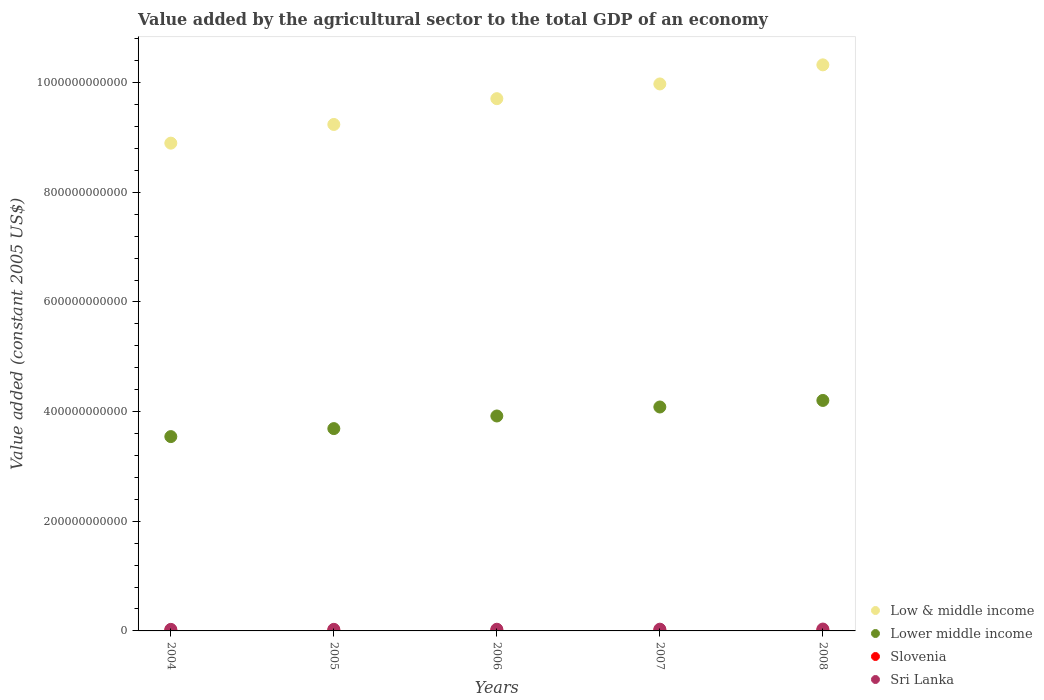How many different coloured dotlines are there?
Offer a terse response. 4. Is the number of dotlines equal to the number of legend labels?
Your answer should be very brief. Yes. What is the value added by the agricultural sector in Low & middle income in 2008?
Your answer should be very brief. 1.03e+12. Across all years, what is the maximum value added by the agricultural sector in Lower middle income?
Ensure brevity in your answer.  4.20e+11. Across all years, what is the minimum value added by the agricultural sector in Low & middle income?
Offer a terse response. 8.90e+11. In which year was the value added by the agricultural sector in Slovenia maximum?
Keep it short and to the point. 2004. What is the total value added by the agricultural sector in Slovenia in the graph?
Provide a succinct answer. 4.28e+09. What is the difference between the value added by the agricultural sector in Low & middle income in 2006 and that in 2008?
Offer a terse response. -6.17e+1. What is the difference between the value added by the agricultural sector in Low & middle income in 2004 and the value added by the agricultural sector in Slovenia in 2005?
Your answer should be very brief. 8.89e+11. What is the average value added by the agricultural sector in Lower middle income per year?
Provide a short and direct response. 3.89e+11. In the year 2004, what is the difference between the value added by the agricultural sector in Slovenia and value added by the agricultural sector in Lower middle income?
Provide a short and direct response. -3.54e+11. What is the ratio of the value added by the agricultural sector in Slovenia in 2005 to that in 2007?
Keep it short and to the point. 0.96. Is the value added by the agricultural sector in Sri Lanka in 2004 less than that in 2008?
Your response must be concise. Yes. What is the difference between the highest and the second highest value added by the agricultural sector in Sri Lanka?
Give a very brief answer. 2.39e+08. What is the difference between the highest and the lowest value added by the agricultural sector in Slovenia?
Offer a very short reply. 5.58e+07. In how many years, is the value added by the agricultural sector in Sri Lanka greater than the average value added by the agricultural sector in Sri Lanka taken over all years?
Ensure brevity in your answer.  2. Is the sum of the value added by the agricultural sector in Low & middle income in 2005 and 2008 greater than the maximum value added by the agricultural sector in Slovenia across all years?
Provide a short and direct response. Yes. Is it the case that in every year, the sum of the value added by the agricultural sector in Low & middle income and value added by the agricultural sector in Slovenia  is greater than the sum of value added by the agricultural sector in Sri Lanka and value added by the agricultural sector in Lower middle income?
Your response must be concise. Yes. Is it the case that in every year, the sum of the value added by the agricultural sector in Slovenia and value added by the agricultural sector in Sri Lanka  is greater than the value added by the agricultural sector in Low & middle income?
Your answer should be compact. No. Does the value added by the agricultural sector in Sri Lanka monotonically increase over the years?
Provide a succinct answer. Yes. Is the value added by the agricultural sector in Low & middle income strictly greater than the value added by the agricultural sector in Lower middle income over the years?
Your answer should be compact. Yes. How many years are there in the graph?
Your answer should be compact. 5. What is the difference between two consecutive major ticks on the Y-axis?
Provide a succinct answer. 2.00e+11. Are the values on the major ticks of Y-axis written in scientific E-notation?
Ensure brevity in your answer.  No. Does the graph contain any zero values?
Your response must be concise. No. Does the graph contain grids?
Provide a succinct answer. No. Where does the legend appear in the graph?
Your answer should be very brief. Bottom right. What is the title of the graph?
Your answer should be very brief. Value added by the agricultural sector to the total GDP of an economy. Does "Bahrain" appear as one of the legend labels in the graph?
Your answer should be compact. No. What is the label or title of the X-axis?
Provide a succinct answer. Years. What is the label or title of the Y-axis?
Provide a short and direct response. Value added (constant 2005 US$). What is the Value added (constant 2005 US$) of Low & middle income in 2004?
Offer a terse response. 8.90e+11. What is the Value added (constant 2005 US$) in Lower middle income in 2004?
Provide a short and direct response. 3.54e+11. What is the Value added (constant 2005 US$) of Slovenia in 2004?
Your response must be concise. 8.80e+08. What is the Value added (constant 2005 US$) of Sri Lanka in 2004?
Make the answer very short. 2.83e+09. What is the Value added (constant 2005 US$) of Low & middle income in 2005?
Your response must be concise. 9.24e+11. What is the Value added (constant 2005 US$) of Lower middle income in 2005?
Offer a terse response. 3.69e+11. What is the Value added (constant 2005 US$) of Slovenia in 2005?
Your answer should be very brief. 8.31e+08. What is the Value added (constant 2005 US$) of Sri Lanka in 2005?
Provide a short and direct response. 2.88e+09. What is the Value added (constant 2005 US$) in Low & middle income in 2006?
Make the answer very short. 9.71e+11. What is the Value added (constant 2005 US$) of Lower middle income in 2006?
Keep it short and to the point. 3.92e+11. What is the Value added (constant 2005 US$) of Slovenia in 2006?
Provide a succinct answer. 8.24e+08. What is the Value added (constant 2005 US$) in Sri Lanka in 2006?
Make the answer very short. 3.07e+09. What is the Value added (constant 2005 US$) of Low & middle income in 2007?
Ensure brevity in your answer.  9.98e+11. What is the Value added (constant 2005 US$) in Lower middle income in 2007?
Your answer should be compact. 4.08e+11. What is the Value added (constant 2005 US$) of Slovenia in 2007?
Your answer should be very brief. 8.68e+08. What is the Value added (constant 2005 US$) in Sri Lanka in 2007?
Keep it short and to the point. 3.17e+09. What is the Value added (constant 2005 US$) of Low & middle income in 2008?
Your answer should be compact. 1.03e+12. What is the Value added (constant 2005 US$) of Lower middle income in 2008?
Your answer should be very brief. 4.20e+11. What is the Value added (constant 2005 US$) in Slovenia in 2008?
Ensure brevity in your answer.  8.73e+08. What is the Value added (constant 2005 US$) in Sri Lanka in 2008?
Keep it short and to the point. 3.41e+09. Across all years, what is the maximum Value added (constant 2005 US$) in Low & middle income?
Provide a short and direct response. 1.03e+12. Across all years, what is the maximum Value added (constant 2005 US$) in Lower middle income?
Offer a very short reply. 4.20e+11. Across all years, what is the maximum Value added (constant 2005 US$) of Slovenia?
Keep it short and to the point. 8.80e+08. Across all years, what is the maximum Value added (constant 2005 US$) in Sri Lanka?
Your answer should be compact. 3.41e+09. Across all years, what is the minimum Value added (constant 2005 US$) in Low & middle income?
Keep it short and to the point. 8.90e+11. Across all years, what is the minimum Value added (constant 2005 US$) in Lower middle income?
Your answer should be very brief. 3.54e+11. Across all years, what is the minimum Value added (constant 2005 US$) in Slovenia?
Ensure brevity in your answer.  8.24e+08. Across all years, what is the minimum Value added (constant 2005 US$) in Sri Lanka?
Provide a short and direct response. 2.83e+09. What is the total Value added (constant 2005 US$) of Low & middle income in the graph?
Your response must be concise. 4.81e+12. What is the total Value added (constant 2005 US$) of Lower middle income in the graph?
Give a very brief answer. 1.94e+12. What is the total Value added (constant 2005 US$) of Slovenia in the graph?
Make the answer very short. 4.28e+09. What is the total Value added (constant 2005 US$) of Sri Lanka in the graph?
Give a very brief answer. 1.54e+1. What is the difference between the Value added (constant 2005 US$) of Low & middle income in 2004 and that in 2005?
Give a very brief answer. -3.41e+1. What is the difference between the Value added (constant 2005 US$) of Lower middle income in 2004 and that in 2005?
Provide a succinct answer. -1.46e+1. What is the difference between the Value added (constant 2005 US$) in Slovenia in 2004 and that in 2005?
Provide a short and direct response. 4.92e+07. What is the difference between the Value added (constant 2005 US$) of Sri Lanka in 2004 and that in 2005?
Keep it short and to the point. -5.15e+07. What is the difference between the Value added (constant 2005 US$) in Low & middle income in 2004 and that in 2006?
Offer a terse response. -8.11e+1. What is the difference between the Value added (constant 2005 US$) of Lower middle income in 2004 and that in 2006?
Your answer should be compact. -3.76e+1. What is the difference between the Value added (constant 2005 US$) of Slovenia in 2004 and that in 2006?
Provide a short and direct response. 5.58e+07. What is the difference between the Value added (constant 2005 US$) in Sri Lanka in 2004 and that in 2006?
Give a very brief answer. -2.34e+08. What is the difference between the Value added (constant 2005 US$) of Low & middle income in 2004 and that in 2007?
Give a very brief answer. -1.08e+11. What is the difference between the Value added (constant 2005 US$) of Lower middle income in 2004 and that in 2007?
Provide a succinct answer. -5.40e+1. What is the difference between the Value added (constant 2005 US$) in Slovenia in 2004 and that in 2007?
Offer a terse response. 1.13e+07. What is the difference between the Value added (constant 2005 US$) in Sri Lanka in 2004 and that in 2007?
Ensure brevity in your answer.  -3.38e+08. What is the difference between the Value added (constant 2005 US$) in Low & middle income in 2004 and that in 2008?
Ensure brevity in your answer.  -1.43e+11. What is the difference between the Value added (constant 2005 US$) in Lower middle income in 2004 and that in 2008?
Offer a very short reply. -6.59e+1. What is the difference between the Value added (constant 2005 US$) in Slovenia in 2004 and that in 2008?
Your answer should be very brief. 6.95e+06. What is the difference between the Value added (constant 2005 US$) of Sri Lanka in 2004 and that in 2008?
Ensure brevity in your answer.  -5.77e+08. What is the difference between the Value added (constant 2005 US$) in Low & middle income in 2005 and that in 2006?
Offer a very short reply. -4.70e+1. What is the difference between the Value added (constant 2005 US$) in Lower middle income in 2005 and that in 2006?
Provide a succinct answer. -2.30e+1. What is the difference between the Value added (constant 2005 US$) in Slovenia in 2005 and that in 2006?
Provide a short and direct response. 6.61e+06. What is the difference between the Value added (constant 2005 US$) of Sri Lanka in 2005 and that in 2006?
Give a very brief answer. -1.82e+08. What is the difference between the Value added (constant 2005 US$) of Low & middle income in 2005 and that in 2007?
Keep it short and to the point. -7.39e+1. What is the difference between the Value added (constant 2005 US$) in Lower middle income in 2005 and that in 2007?
Provide a succinct answer. -3.94e+1. What is the difference between the Value added (constant 2005 US$) of Slovenia in 2005 and that in 2007?
Keep it short and to the point. -3.79e+07. What is the difference between the Value added (constant 2005 US$) of Sri Lanka in 2005 and that in 2007?
Your answer should be compact. -2.86e+08. What is the difference between the Value added (constant 2005 US$) of Low & middle income in 2005 and that in 2008?
Offer a terse response. -1.09e+11. What is the difference between the Value added (constant 2005 US$) in Lower middle income in 2005 and that in 2008?
Your answer should be compact. -5.14e+1. What is the difference between the Value added (constant 2005 US$) in Slovenia in 2005 and that in 2008?
Offer a terse response. -4.22e+07. What is the difference between the Value added (constant 2005 US$) of Sri Lanka in 2005 and that in 2008?
Offer a terse response. -5.25e+08. What is the difference between the Value added (constant 2005 US$) in Low & middle income in 2006 and that in 2007?
Your answer should be very brief. -2.69e+1. What is the difference between the Value added (constant 2005 US$) of Lower middle income in 2006 and that in 2007?
Give a very brief answer. -1.64e+1. What is the difference between the Value added (constant 2005 US$) of Slovenia in 2006 and that in 2007?
Your response must be concise. -4.45e+07. What is the difference between the Value added (constant 2005 US$) of Sri Lanka in 2006 and that in 2007?
Offer a very short reply. -1.04e+08. What is the difference between the Value added (constant 2005 US$) in Low & middle income in 2006 and that in 2008?
Your answer should be very brief. -6.17e+1. What is the difference between the Value added (constant 2005 US$) in Lower middle income in 2006 and that in 2008?
Your response must be concise. -2.84e+1. What is the difference between the Value added (constant 2005 US$) of Slovenia in 2006 and that in 2008?
Offer a terse response. -4.88e+07. What is the difference between the Value added (constant 2005 US$) of Sri Lanka in 2006 and that in 2008?
Your answer should be compact. -3.43e+08. What is the difference between the Value added (constant 2005 US$) in Low & middle income in 2007 and that in 2008?
Ensure brevity in your answer.  -3.48e+1. What is the difference between the Value added (constant 2005 US$) in Lower middle income in 2007 and that in 2008?
Your answer should be compact. -1.20e+1. What is the difference between the Value added (constant 2005 US$) in Slovenia in 2007 and that in 2008?
Offer a very short reply. -4.32e+06. What is the difference between the Value added (constant 2005 US$) of Sri Lanka in 2007 and that in 2008?
Your answer should be compact. -2.39e+08. What is the difference between the Value added (constant 2005 US$) of Low & middle income in 2004 and the Value added (constant 2005 US$) of Lower middle income in 2005?
Your answer should be compact. 5.21e+11. What is the difference between the Value added (constant 2005 US$) of Low & middle income in 2004 and the Value added (constant 2005 US$) of Slovenia in 2005?
Offer a terse response. 8.89e+11. What is the difference between the Value added (constant 2005 US$) of Low & middle income in 2004 and the Value added (constant 2005 US$) of Sri Lanka in 2005?
Your answer should be compact. 8.87e+11. What is the difference between the Value added (constant 2005 US$) in Lower middle income in 2004 and the Value added (constant 2005 US$) in Slovenia in 2005?
Ensure brevity in your answer.  3.54e+11. What is the difference between the Value added (constant 2005 US$) of Lower middle income in 2004 and the Value added (constant 2005 US$) of Sri Lanka in 2005?
Ensure brevity in your answer.  3.52e+11. What is the difference between the Value added (constant 2005 US$) in Slovenia in 2004 and the Value added (constant 2005 US$) in Sri Lanka in 2005?
Your answer should be very brief. -2.00e+09. What is the difference between the Value added (constant 2005 US$) of Low & middle income in 2004 and the Value added (constant 2005 US$) of Lower middle income in 2006?
Your answer should be compact. 4.98e+11. What is the difference between the Value added (constant 2005 US$) in Low & middle income in 2004 and the Value added (constant 2005 US$) in Slovenia in 2006?
Provide a short and direct response. 8.89e+11. What is the difference between the Value added (constant 2005 US$) in Low & middle income in 2004 and the Value added (constant 2005 US$) in Sri Lanka in 2006?
Your answer should be very brief. 8.87e+11. What is the difference between the Value added (constant 2005 US$) of Lower middle income in 2004 and the Value added (constant 2005 US$) of Slovenia in 2006?
Offer a very short reply. 3.54e+11. What is the difference between the Value added (constant 2005 US$) in Lower middle income in 2004 and the Value added (constant 2005 US$) in Sri Lanka in 2006?
Your response must be concise. 3.51e+11. What is the difference between the Value added (constant 2005 US$) of Slovenia in 2004 and the Value added (constant 2005 US$) of Sri Lanka in 2006?
Your answer should be compact. -2.19e+09. What is the difference between the Value added (constant 2005 US$) of Low & middle income in 2004 and the Value added (constant 2005 US$) of Lower middle income in 2007?
Offer a terse response. 4.81e+11. What is the difference between the Value added (constant 2005 US$) in Low & middle income in 2004 and the Value added (constant 2005 US$) in Slovenia in 2007?
Offer a terse response. 8.89e+11. What is the difference between the Value added (constant 2005 US$) in Low & middle income in 2004 and the Value added (constant 2005 US$) in Sri Lanka in 2007?
Provide a succinct answer. 8.87e+11. What is the difference between the Value added (constant 2005 US$) of Lower middle income in 2004 and the Value added (constant 2005 US$) of Slovenia in 2007?
Ensure brevity in your answer.  3.54e+11. What is the difference between the Value added (constant 2005 US$) in Lower middle income in 2004 and the Value added (constant 2005 US$) in Sri Lanka in 2007?
Keep it short and to the point. 3.51e+11. What is the difference between the Value added (constant 2005 US$) in Slovenia in 2004 and the Value added (constant 2005 US$) in Sri Lanka in 2007?
Your answer should be very brief. -2.29e+09. What is the difference between the Value added (constant 2005 US$) in Low & middle income in 2004 and the Value added (constant 2005 US$) in Lower middle income in 2008?
Offer a very short reply. 4.69e+11. What is the difference between the Value added (constant 2005 US$) in Low & middle income in 2004 and the Value added (constant 2005 US$) in Slovenia in 2008?
Provide a short and direct response. 8.89e+11. What is the difference between the Value added (constant 2005 US$) in Low & middle income in 2004 and the Value added (constant 2005 US$) in Sri Lanka in 2008?
Provide a short and direct response. 8.86e+11. What is the difference between the Value added (constant 2005 US$) in Lower middle income in 2004 and the Value added (constant 2005 US$) in Slovenia in 2008?
Your response must be concise. 3.54e+11. What is the difference between the Value added (constant 2005 US$) of Lower middle income in 2004 and the Value added (constant 2005 US$) of Sri Lanka in 2008?
Give a very brief answer. 3.51e+11. What is the difference between the Value added (constant 2005 US$) of Slovenia in 2004 and the Value added (constant 2005 US$) of Sri Lanka in 2008?
Provide a short and direct response. -2.53e+09. What is the difference between the Value added (constant 2005 US$) of Low & middle income in 2005 and the Value added (constant 2005 US$) of Lower middle income in 2006?
Your answer should be very brief. 5.32e+11. What is the difference between the Value added (constant 2005 US$) of Low & middle income in 2005 and the Value added (constant 2005 US$) of Slovenia in 2006?
Provide a short and direct response. 9.23e+11. What is the difference between the Value added (constant 2005 US$) of Low & middle income in 2005 and the Value added (constant 2005 US$) of Sri Lanka in 2006?
Keep it short and to the point. 9.21e+11. What is the difference between the Value added (constant 2005 US$) of Lower middle income in 2005 and the Value added (constant 2005 US$) of Slovenia in 2006?
Ensure brevity in your answer.  3.68e+11. What is the difference between the Value added (constant 2005 US$) in Lower middle income in 2005 and the Value added (constant 2005 US$) in Sri Lanka in 2006?
Provide a short and direct response. 3.66e+11. What is the difference between the Value added (constant 2005 US$) of Slovenia in 2005 and the Value added (constant 2005 US$) of Sri Lanka in 2006?
Your answer should be very brief. -2.24e+09. What is the difference between the Value added (constant 2005 US$) in Low & middle income in 2005 and the Value added (constant 2005 US$) in Lower middle income in 2007?
Keep it short and to the point. 5.15e+11. What is the difference between the Value added (constant 2005 US$) of Low & middle income in 2005 and the Value added (constant 2005 US$) of Slovenia in 2007?
Your answer should be very brief. 9.23e+11. What is the difference between the Value added (constant 2005 US$) in Low & middle income in 2005 and the Value added (constant 2005 US$) in Sri Lanka in 2007?
Offer a terse response. 9.21e+11. What is the difference between the Value added (constant 2005 US$) of Lower middle income in 2005 and the Value added (constant 2005 US$) of Slovenia in 2007?
Provide a short and direct response. 3.68e+11. What is the difference between the Value added (constant 2005 US$) of Lower middle income in 2005 and the Value added (constant 2005 US$) of Sri Lanka in 2007?
Provide a succinct answer. 3.66e+11. What is the difference between the Value added (constant 2005 US$) in Slovenia in 2005 and the Value added (constant 2005 US$) in Sri Lanka in 2007?
Offer a terse response. -2.34e+09. What is the difference between the Value added (constant 2005 US$) in Low & middle income in 2005 and the Value added (constant 2005 US$) in Lower middle income in 2008?
Make the answer very short. 5.03e+11. What is the difference between the Value added (constant 2005 US$) of Low & middle income in 2005 and the Value added (constant 2005 US$) of Slovenia in 2008?
Make the answer very short. 9.23e+11. What is the difference between the Value added (constant 2005 US$) of Low & middle income in 2005 and the Value added (constant 2005 US$) of Sri Lanka in 2008?
Provide a succinct answer. 9.20e+11. What is the difference between the Value added (constant 2005 US$) in Lower middle income in 2005 and the Value added (constant 2005 US$) in Slovenia in 2008?
Provide a succinct answer. 3.68e+11. What is the difference between the Value added (constant 2005 US$) in Lower middle income in 2005 and the Value added (constant 2005 US$) in Sri Lanka in 2008?
Provide a succinct answer. 3.66e+11. What is the difference between the Value added (constant 2005 US$) of Slovenia in 2005 and the Value added (constant 2005 US$) of Sri Lanka in 2008?
Offer a terse response. -2.58e+09. What is the difference between the Value added (constant 2005 US$) of Low & middle income in 2006 and the Value added (constant 2005 US$) of Lower middle income in 2007?
Offer a terse response. 5.62e+11. What is the difference between the Value added (constant 2005 US$) of Low & middle income in 2006 and the Value added (constant 2005 US$) of Slovenia in 2007?
Provide a succinct answer. 9.70e+11. What is the difference between the Value added (constant 2005 US$) in Low & middle income in 2006 and the Value added (constant 2005 US$) in Sri Lanka in 2007?
Make the answer very short. 9.68e+11. What is the difference between the Value added (constant 2005 US$) of Lower middle income in 2006 and the Value added (constant 2005 US$) of Slovenia in 2007?
Provide a short and direct response. 3.91e+11. What is the difference between the Value added (constant 2005 US$) in Lower middle income in 2006 and the Value added (constant 2005 US$) in Sri Lanka in 2007?
Your response must be concise. 3.89e+11. What is the difference between the Value added (constant 2005 US$) of Slovenia in 2006 and the Value added (constant 2005 US$) of Sri Lanka in 2007?
Your answer should be compact. -2.35e+09. What is the difference between the Value added (constant 2005 US$) of Low & middle income in 2006 and the Value added (constant 2005 US$) of Lower middle income in 2008?
Offer a terse response. 5.50e+11. What is the difference between the Value added (constant 2005 US$) of Low & middle income in 2006 and the Value added (constant 2005 US$) of Slovenia in 2008?
Provide a short and direct response. 9.70e+11. What is the difference between the Value added (constant 2005 US$) of Low & middle income in 2006 and the Value added (constant 2005 US$) of Sri Lanka in 2008?
Offer a very short reply. 9.67e+11. What is the difference between the Value added (constant 2005 US$) of Lower middle income in 2006 and the Value added (constant 2005 US$) of Slovenia in 2008?
Your answer should be compact. 3.91e+11. What is the difference between the Value added (constant 2005 US$) in Lower middle income in 2006 and the Value added (constant 2005 US$) in Sri Lanka in 2008?
Ensure brevity in your answer.  3.89e+11. What is the difference between the Value added (constant 2005 US$) in Slovenia in 2006 and the Value added (constant 2005 US$) in Sri Lanka in 2008?
Your response must be concise. -2.59e+09. What is the difference between the Value added (constant 2005 US$) in Low & middle income in 2007 and the Value added (constant 2005 US$) in Lower middle income in 2008?
Give a very brief answer. 5.77e+11. What is the difference between the Value added (constant 2005 US$) of Low & middle income in 2007 and the Value added (constant 2005 US$) of Slovenia in 2008?
Your response must be concise. 9.97e+11. What is the difference between the Value added (constant 2005 US$) of Low & middle income in 2007 and the Value added (constant 2005 US$) of Sri Lanka in 2008?
Give a very brief answer. 9.94e+11. What is the difference between the Value added (constant 2005 US$) of Lower middle income in 2007 and the Value added (constant 2005 US$) of Slovenia in 2008?
Your answer should be very brief. 4.08e+11. What is the difference between the Value added (constant 2005 US$) in Lower middle income in 2007 and the Value added (constant 2005 US$) in Sri Lanka in 2008?
Offer a very short reply. 4.05e+11. What is the difference between the Value added (constant 2005 US$) in Slovenia in 2007 and the Value added (constant 2005 US$) in Sri Lanka in 2008?
Ensure brevity in your answer.  -2.54e+09. What is the average Value added (constant 2005 US$) of Low & middle income per year?
Your response must be concise. 9.63e+11. What is the average Value added (constant 2005 US$) of Lower middle income per year?
Keep it short and to the point. 3.89e+11. What is the average Value added (constant 2005 US$) in Slovenia per year?
Your answer should be very brief. 8.55e+08. What is the average Value added (constant 2005 US$) of Sri Lanka per year?
Your answer should be compact. 3.07e+09. In the year 2004, what is the difference between the Value added (constant 2005 US$) in Low & middle income and Value added (constant 2005 US$) in Lower middle income?
Offer a terse response. 5.35e+11. In the year 2004, what is the difference between the Value added (constant 2005 US$) in Low & middle income and Value added (constant 2005 US$) in Slovenia?
Provide a succinct answer. 8.89e+11. In the year 2004, what is the difference between the Value added (constant 2005 US$) in Low & middle income and Value added (constant 2005 US$) in Sri Lanka?
Give a very brief answer. 8.87e+11. In the year 2004, what is the difference between the Value added (constant 2005 US$) in Lower middle income and Value added (constant 2005 US$) in Slovenia?
Ensure brevity in your answer.  3.54e+11. In the year 2004, what is the difference between the Value added (constant 2005 US$) in Lower middle income and Value added (constant 2005 US$) in Sri Lanka?
Ensure brevity in your answer.  3.52e+11. In the year 2004, what is the difference between the Value added (constant 2005 US$) in Slovenia and Value added (constant 2005 US$) in Sri Lanka?
Ensure brevity in your answer.  -1.95e+09. In the year 2005, what is the difference between the Value added (constant 2005 US$) in Low & middle income and Value added (constant 2005 US$) in Lower middle income?
Your response must be concise. 5.55e+11. In the year 2005, what is the difference between the Value added (constant 2005 US$) in Low & middle income and Value added (constant 2005 US$) in Slovenia?
Offer a very short reply. 9.23e+11. In the year 2005, what is the difference between the Value added (constant 2005 US$) of Low & middle income and Value added (constant 2005 US$) of Sri Lanka?
Offer a very short reply. 9.21e+11. In the year 2005, what is the difference between the Value added (constant 2005 US$) of Lower middle income and Value added (constant 2005 US$) of Slovenia?
Your response must be concise. 3.68e+11. In the year 2005, what is the difference between the Value added (constant 2005 US$) in Lower middle income and Value added (constant 2005 US$) in Sri Lanka?
Make the answer very short. 3.66e+11. In the year 2005, what is the difference between the Value added (constant 2005 US$) of Slovenia and Value added (constant 2005 US$) of Sri Lanka?
Give a very brief answer. -2.05e+09. In the year 2006, what is the difference between the Value added (constant 2005 US$) of Low & middle income and Value added (constant 2005 US$) of Lower middle income?
Offer a terse response. 5.79e+11. In the year 2006, what is the difference between the Value added (constant 2005 US$) in Low & middle income and Value added (constant 2005 US$) in Slovenia?
Your answer should be compact. 9.70e+11. In the year 2006, what is the difference between the Value added (constant 2005 US$) of Low & middle income and Value added (constant 2005 US$) of Sri Lanka?
Your answer should be very brief. 9.68e+11. In the year 2006, what is the difference between the Value added (constant 2005 US$) of Lower middle income and Value added (constant 2005 US$) of Slovenia?
Give a very brief answer. 3.91e+11. In the year 2006, what is the difference between the Value added (constant 2005 US$) in Lower middle income and Value added (constant 2005 US$) in Sri Lanka?
Your answer should be compact. 3.89e+11. In the year 2006, what is the difference between the Value added (constant 2005 US$) of Slovenia and Value added (constant 2005 US$) of Sri Lanka?
Provide a short and direct response. -2.24e+09. In the year 2007, what is the difference between the Value added (constant 2005 US$) in Low & middle income and Value added (constant 2005 US$) in Lower middle income?
Offer a terse response. 5.89e+11. In the year 2007, what is the difference between the Value added (constant 2005 US$) of Low & middle income and Value added (constant 2005 US$) of Slovenia?
Your answer should be compact. 9.97e+11. In the year 2007, what is the difference between the Value added (constant 2005 US$) of Low & middle income and Value added (constant 2005 US$) of Sri Lanka?
Offer a very short reply. 9.95e+11. In the year 2007, what is the difference between the Value added (constant 2005 US$) in Lower middle income and Value added (constant 2005 US$) in Slovenia?
Offer a very short reply. 4.08e+11. In the year 2007, what is the difference between the Value added (constant 2005 US$) in Lower middle income and Value added (constant 2005 US$) in Sri Lanka?
Keep it short and to the point. 4.05e+11. In the year 2007, what is the difference between the Value added (constant 2005 US$) of Slovenia and Value added (constant 2005 US$) of Sri Lanka?
Offer a terse response. -2.30e+09. In the year 2008, what is the difference between the Value added (constant 2005 US$) in Low & middle income and Value added (constant 2005 US$) in Lower middle income?
Give a very brief answer. 6.12e+11. In the year 2008, what is the difference between the Value added (constant 2005 US$) in Low & middle income and Value added (constant 2005 US$) in Slovenia?
Keep it short and to the point. 1.03e+12. In the year 2008, what is the difference between the Value added (constant 2005 US$) in Low & middle income and Value added (constant 2005 US$) in Sri Lanka?
Your answer should be compact. 1.03e+12. In the year 2008, what is the difference between the Value added (constant 2005 US$) in Lower middle income and Value added (constant 2005 US$) in Slovenia?
Make the answer very short. 4.20e+11. In the year 2008, what is the difference between the Value added (constant 2005 US$) of Lower middle income and Value added (constant 2005 US$) of Sri Lanka?
Your response must be concise. 4.17e+11. In the year 2008, what is the difference between the Value added (constant 2005 US$) in Slovenia and Value added (constant 2005 US$) in Sri Lanka?
Offer a very short reply. -2.54e+09. What is the ratio of the Value added (constant 2005 US$) of Low & middle income in 2004 to that in 2005?
Give a very brief answer. 0.96. What is the ratio of the Value added (constant 2005 US$) of Lower middle income in 2004 to that in 2005?
Provide a short and direct response. 0.96. What is the ratio of the Value added (constant 2005 US$) of Slovenia in 2004 to that in 2005?
Keep it short and to the point. 1.06. What is the ratio of the Value added (constant 2005 US$) of Sri Lanka in 2004 to that in 2005?
Provide a succinct answer. 0.98. What is the ratio of the Value added (constant 2005 US$) in Low & middle income in 2004 to that in 2006?
Offer a terse response. 0.92. What is the ratio of the Value added (constant 2005 US$) of Lower middle income in 2004 to that in 2006?
Your answer should be very brief. 0.9. What is the ratio of the Value added (constant 2005 US$) of Slovenia in 2004 to that in 2006?
Make the answer very short. 1.07. What is the ratio of the Value added (constant 2005 US$) in Sri Lanka in 2004 to that in 2006?
Keep it short and to the point. 0.92. What is the ratio of the Value added (constant 2005 US$) in Low & middle income in 2004 to that in 2007?
Your response must be concise. 0.89. What is the ratio of the Value added (constant 2005 US$) in Lower middle income in 2004 to that in 2007?
Provide a short and direct response. 0.87. What is the ratio of the Value added (constant 2005 US$) of Slovenia in 2004 to that in 2007?
Your answer should be compact. 1.01. What is the ratio of the Value added (constant 2005 US$) in Sri Lanka in 2004 to that in 2007?
Provide a short and direct response. 0.89. What is the ratio of the Value added (constant 2005 US$) of Low & middle income in 2004 to that in 2008?
Your answer should be very brief. 0.86. What is the ratio of the Value added (constant 2005 US$) of Lower middle income in 2004 to that in 2008?
Provide a succinct answer. 0.84. What is the ratio of the Value added (constant 2005 US$) in Sri Lanka in 2004 to that in 2008?
Make the answer very short. 0.83. What is the ratio of the Value added (constant 2005 US$) of Low & middle income in 2005 to that in 2006?
Your answer should be compact. 0.95. What is the ratio of the Value added (constant 2005 US$) of Lower middle income in 2005 to that in 2006?
Your answer should be compact. 0.94. What is the ratio of the Value added (constant 2005 US$) in Slovenia in 2005 to that in 2006?
Your answer should be compact. 1.01. What is the ratio of the Value added (constant 2005 US$) of Sri Lanka in 2005 to that in 2006?
Give a very brief answer. 0.94. What is the ratio of the Value added (constant 2005 US$) in Low & middle income in 2005 to that in 2007?
Ensure brevity in your answer.  0.93. What is the ratio of the Value added (constant 2005 US$) in Lower middle income in 2005 to that in 2007?
Keep it short and to the point. 0.9. What is the ratio of the Value added (constant 2005 US$) of Slovenia in 2005 to that in 2007?
Ensure brevity in your answer.  0.96. What is the ratio of the Value added (constant 2005 US$) of Sri Lanka in 2005 to that in 2007?
Ensure brevity in your answer.  0.91. What is the ratio of the Value added (constant 2005 US$) in Low & middle income in 2005 to that in 2008?
Give a very brief answer. 0.89. What is the ratio of the Value added (constant 2005 US$) in Lower middle income in 2005 to that in 2008?
Provide a short and direct response. 0.88. What is the ratio of the Value added (constant 2005 US$) in Slovenia in 2005 to that in 2008?
Your response must be concise. 0.95. What is the ratio of the Value added (constant 2005 US$) in Sri Lanka in 2005 to that in 2008?
Offer a very short reply. 0.85. What is the ratio of the Value added (constant 2005 US$) of Low & middle income in 2006 to that in 2007?
Ensure brevity in your answer.  0.97. What is the ratio of the Value added (constant 2005 US$) in Lower middle income in 2006 to that in 2007?
Provide a succinct answer. 0.96. What is the ratio of the Value added (constant 2005 US$) in Slovenia in 2006 to that in 2007?
Ensure brevity in your answer.  0.95. What is the ratio of the Value added (constant 2005 US$) in Sri Lanka in 2006 to that in 2007?
Your answer should be compact. 0.97. What is the ratio of the Value added (constant 2005 US$) in Low & middle income in 2006 to that in 2008?
Offer a terse response. 0.94. What is the ratio of the Value added (constant 2005 US$) of Lower middle income in 2006 to that in 2008?
Offer a very short reply. 0.93. What is the ratio of the Value added (constant 2005 US$) in Slovenia in 2006 to that in 2008?
Give a very brief answer. 0.94. What is the ratio of the Value added (constant 2005 US$) of Sri Lanka in 2006 to that in 2008?
Offer a very short reply. 0.9. What is the ratio of the Value added (constant 2005 US$) in Low & middle income in 2007 to that in 2008?
Provide a succinct answer. 0.97. What is the ratio of the Value added (constant 2005 US$) in Lower middle income in 2007 to that in 2008?
Your answer should be compact. 0.97. What is the ratio of the Value added (constant 2005 US$) in Sri Lanka in 2007 to that in 2008?
Ensure brevity in your answer.  0.93. What is the difference between the highest and the second highest Value added (constant 2005 US$) in Low & middle income?
Offer a terse response. 3.48e+1. What is the difference between the highest and the second highest Value added (constant 2005 US$) in Lower middle income?
Ensure brevity in your answer.  1.20e+1. What is the difference between the highest and the second highest Value added (constant 2005 US$) in Slovenia?
Provide a succinct answer. 6.95e+06. What is the difference between the highest and the second highest Value added (constant 2005 US$) of Sri Lanka?
Your answer should be very brief. 2.39e+08. What is the difference between the highest and the lowest Value added (constant 2005 US$) of Low & middle income?
Offer a very short reply. 1.43e+11. What is the difference between the highest and the lowest Value added (constant 2005 US$) in Lower middle income?
Offer a very short reply. 6.59e+1. What is the difference between the highest and the lowest Value added (constant 2005 US$) in Slovenia?
Offer a very short reply. 5.58e+07. What is the difference between the highest and the lowest Value added (constant 2005 US$) in Sri Lanka?
Ensure brevity in your answer.  5.77e+08. 